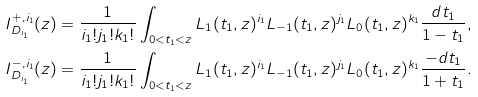Convert formula to latex. <formula><loc_0><loc_0><loc_500><loc_500>I _ { D _ { i _ { 1 } } } ^ { + , i _ { 1 } } ( z ) = \frac { 1 } { i _ { 1 } ! j _ { 1 } ! k _ { 1 } ! } \int _ { 0 < t _ { 1 } < z } L _ { 1 } ( t _ { 1 } , z ) ^ { i _ { 1 } } L _ { - 1 } ( t _ { 1 } , z ) ^ { j _ { 1 } } L _ { 0 } ( t _ { 1 } , z ) ^ { k _ { 1 } } \frac { d t _ { 1 } } { 1 - t _ { 1 } } , \\ I _ { D _ { i _ { 1 } } } ^ { - , i _ { 1 } } ( z ) = \frac { 1 } { i _ { 1 } ! j _ { 1 } ! k _ { 1 } ! } \int _ { 0 < t _ { 1 } < z } L _ { 1 } ( t _ { 1 } , z ) ^ { i _ { 1 } } L _ { - 1 } ( t _ { 1 } , z ) ^ { j _ { 1 } } L _ { 0 } ( t _ { 1 } , z ) ^ { k _ { 1 } } \frac { - d t _ { 1 } } { 1 + t _ { 1 } } .</formula> 